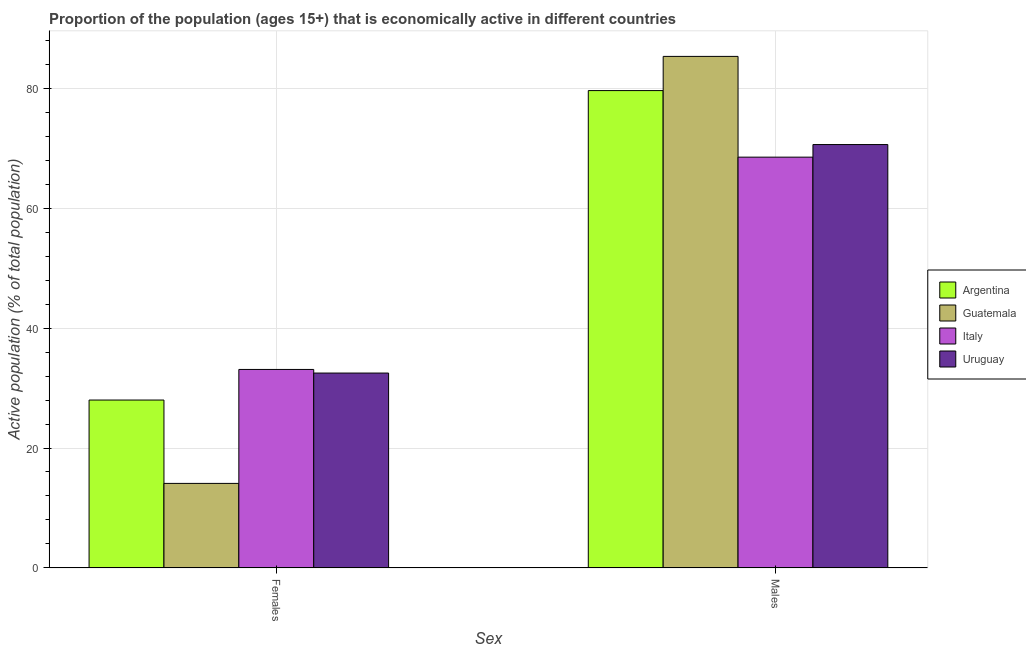Are the number of bars per tick equal to the number of legend labels?
Ensure brevity in your answer.  Yes. Are the number of bars on each tick of the X-axis equal?
Ensure brevity in your answer.  Yes. How many bars are there on the 2nd tick from the left?
Make the answer very short. 4. How many bars are there on the 2nd tick from the right?
Ensure brevity in your answer.  4. What is the label of the 2nd group of bars from the left?
Make the answer very short. Males. What is the percentage of economically active female population in Argentina?
Make the answer very short. 28. Across all countries, what is the maximum percentage of economically active female population?
Give a very brief answer. 33.1. Across all countries, what is the minimum percentage of economically active female population?
Keep it short and to the point. 14.1. In which country was the percentage of economically active female population maximum?
Your answer should be very brief. Italy. What is the total percentage of economically active female population in the graph?
Make the answer very short. 107.7. What is the difference between the percentage of economically active male population in Argentina and the percentage of economically active female population in Guatemala?
Provide a short and direct response. 65.5. What is the average percentage of economically active female population per country?
Your answer should be compact. 26.92. What is the difference between the percentage of economically active female population and percentage of economically active male population in Argentina?
Your answer should be very brief. -51.6. What is the ratio of the percentage of economically active female population in Guatemala to that in Uruguay?
Provide a short and direct response. 0.43. Is the percentage of economically active male population in Uruguay less than that in Argentina?
Offer a terse response. Yes. In how many countries, is the percentage of economically active male population greater than the average percentage of economically active male population taken over all countries?
Make the answer very short. 2. What does the 1st bar from the right in Females represents?
Make the answer very short. Uruguay. How many bars are there?
Your answer should be very brief. 8. Are all the bars in the graph horizontal?
Provide a short and direct response. No. How many countries are there in the graph?
Your answer should be compact. 4. What is the difference between two consecutive major ticks on the Y-axis?
Offer a terse response. 20. Does the graph contain grids?
Provide a short and direct response. Yes. Where does the legend appear in the graph?
Give a very brief answer. Center right. How many legend labels are there?
Offer a terse response. 4. What is the title of the graph?
Make the answer very short. Proportion of the population (ages 15+) that is economically active in different countries. What is the label or title of the X-axis?
Provide a succinct answer. Sex. What is the label or title of the Y-axis?
Make the answer very short. Active population (% of total population). What is the Active population (% of total population) in Guatemala in Females?
Make the answer very short. 14.1. What is the Active population (% of total population) in Italy in Females?
Your answer should be very brief. 33.1. What is the Active population (% of total population) in Uruguay in Females?
Make the answer very short. 32.5. What is the Active population (% of total population) of Argentina in Males?
Your answer should be compact. 79.6. What is the Active population (% of total population) in Guatemala in Males?
Offer a very short reply. 85.3. What is the Active population (% of total population) in Italy in Males?
Provide a succinct answer. 68.5. What is the Active population (% of total population) of Uruguay in Males?
Offer a very short reply. 70.6. Across all Sex, what is the maximum Active population (% of total population) of Argentina?
Make the answer very short. 79.6. Across all Sex, what is the maximum Active population (% of total population) of Guatemala?
Make the answer very short. 85.3. Across all Sex, what is the maximum Active population (% of total population) of Italy?
Give a very brief answer. 68.5. Across all Sex, what is the maximum Active population (% of total population) in Uruguay?
Provide a succinct answer. 70.6. Across all Sex, what is the minimum Active population (% of total population) in Guatemala?
Keep it short and to the point. 14.1. Across all Sex, what is the minimum Active population (% of total population) in Italy?
Your answer should be compact. 33.1. Across all Sex, what is the minimum Active population (% of total population) in Uruguay?
Provide a succinct answer. 32.5. What is the total Active population (% of total population) in Argentina in the graph?
Provide a succinct answer. 107.6. What is the total Active population (% of total population) in Guatemala in the graph?
Provide a succinct answer. 99.4. What is the total Active population (% of total population) in Italy in the graph?
Offer a terse response. 101.6. What is the total Active population (% of total population) in Uruguay in the graph?
Keep it short and to the point. 103.1. What is the difference between the Active population (% of total population) in Argentina in Females and that in Males?
Your answer should be compact. -51.6. What is the difference between the Active population (% of total population) of Guatemala in Females and that in Males?
Your answer should be very brief. -71.2. What is the difference between the Active population (% of total population) of Italy in Females and that in Males?
Your answer should be compact. -35.4. What is the difference between the Active population (% of total population) in Uruguay in Females and that in Males?
Your answer should be compact. -38.1. What is the difference between the Active population (% of total population) of Argentina in Females and the Active population (% of total population) of Guatemala in Males?
Your answer should be very brief. -57.3. What is the difference between the Active population (% of total population) of Argentina in Females and the Active population (% of total population) of Italy in Males?
Give a very brief answer. -40.5. What is the difference between the Active population (% of total population) in Argentina in Females and the Active population (% of total population) in Uruguay in Males?
Your answer should be compact. -42.6. What is the difference between the Active population (% of total population) of Guatemala in Females and the Active population (% of total population) of Italy in Males?
Ensure brevity in your answer.  -54.4. What is the difference between the Active population (% of total population) of Guatemala in Females and the Active population (% of total population) of Uruguay in Males?
Keep it short and to the point. -56.5. What is the difference between the Active population (% of total population) of Italy in Females and the Active population (% of total population) of Uruguay in Males?
Provide a succinct answer. -37.5. What is the average Active population (% of total population) in Argentina per Sex?
Ensure brevity in your answer.  53.8. What is the average Active population (% of total population) in Guatemala per Sex?
Make the answer very short. 49.7. What is the average Active population (% of total population) of Italy per Sex?
Make the answer very short. 50.8. What is the average Active population (% of total population) in Uruguay per Sex?
Offer a very short reply. 51.55. What is the difference between the Active population (% of total population) in Argentina and Active population (% of total population) in Italy in Females?
Make the answer very short. -5.1. What is the difference between the Active population (% of total population) in Argentina and Active population (% of total population) in Uruguay in Females?
Give a very brief answer. -4.5. What is the difference between the Active population (% of total population) of Guatemala and Active population (% of total population) of Uruguay in Females?
Provide a short and direct response. -18.4. What is the difference between the Active population (% of total population) of Italy and Active population (% of total population) of Uruguay in Females?
Keep it short and to the point. 0.6. What is the difference between the Active population (% of total population) in Argentina and Active population (% of total population) in Guatemala in Males?
Provide a succinct answer. -5.7. What is the difference between the Active population (% of total population) of Argentina and Active population (% of total population) of Italy in Males?
Offer a very short reply. 11.1. What is the difference between the Active population (% of total population) in Argentina and Active population (% of total population) in Uruguay in Males?
Provide a succinct answer. 9. What is the difference between the Active population (% of total population) in Guatemala and Active population (% of total population) in Uruguay in Males?
Offer a very short reply. 14.7. What is the difference between the Active population (% of total population) of Italy and Active population (% of total population) of Uruguay in Males?
Ensure brevity in your answer.  -2.1. What is the ratio of the Active population (% of total population) of Argentina in Females to that in Males?
Give a very brief answer. 0.35. What is the ratio of the Active population (% of total population) of Guatemala in Females to that in Males?
Offer a very short reply. 0.17. What is the ratio of the Active population (% of total population) of Italy in Females to that in Males?
Keep it short and to the point. 0.48. What is the ratio of the Active population (% of total population) in Uruguay in Females to that in Males?
Make the answer very short. 0.46. What is the difference between the highest and the second highest Active population (% of total population) in Argentina?
Keep it short and to the point. 51.6. What is the difference between the highest and the second highest Active population (% of total population) in Guatemala?
Provide a succinct answer. 71.2. What is the difference between the highest and the second highest Active population (% of total population) in Italy?
Provide a short and direct response. 35.4. What is the difference between the highest and the second highest Active population (% of total population) of Uruguay?
Provide a short and direct response. 38.1. What is the difference between the highest and the lowest Active population (% of total population) of Argentina?
Your answer should be very brief. 51.6. What is the difference between the highest and the lowest Active population (% of total population) of Guatemala?
Provide a short and direct response. 71.2. What is the difference between the highest and the lowest Active population (% of total population) in Italy?
Offer a terse response. 35.4. What is the difference between the highest and the lowest Active population (% of total population) of Uruguay?
Your answer should be compact. 38.1. 